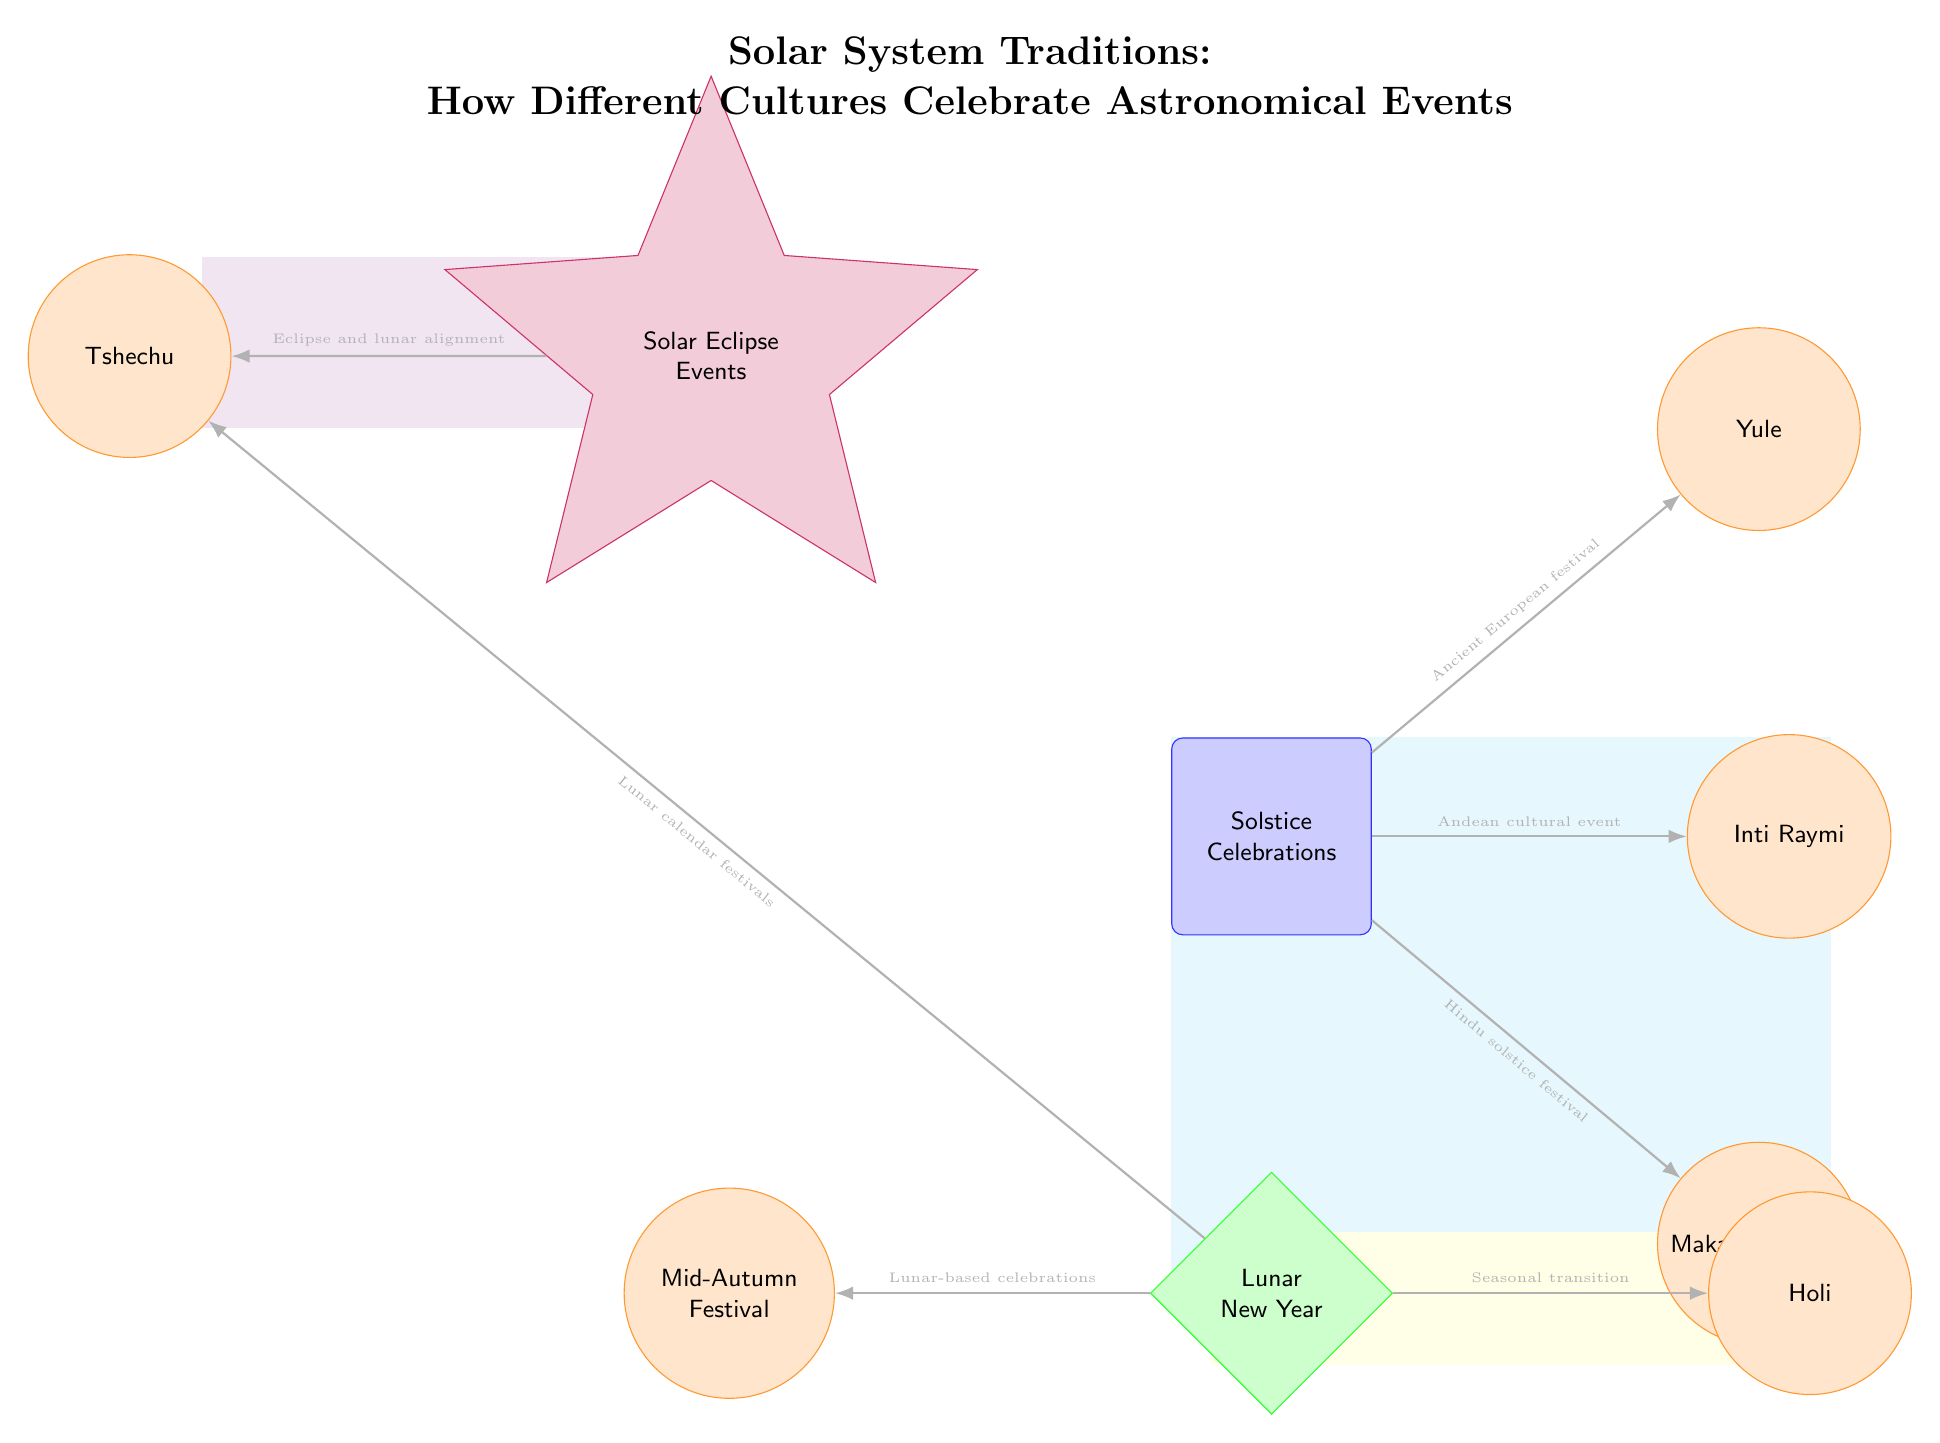What is the main theme of the diagram? The title at the top of the diagram clearly states the theme: "Solar System Traditions: How Different Cultures Celebrate Astronomical Events." This provides an overview of what the diagram will discuss.
Answer: Solar System Traditions: How Different Cultures Celebrate Astronomical Events How many solstice celebrations are shown? There are three events branching from the "Solstice Celebrations" node: Yule, Inti Raymi, and Makar Sankranti. Counting these gives a total of three solstice celebrations.
Answer: 3 Which festival is associated with the lunar calendar? The connections from the "Lunar New Year" show that Mid-Autumn Festival and Tsechu are specifically mentioned as festivals linked to the lunar calendar. Hence, either could be interpreted as an answer, but the question asks for which is directly stated as lunar-based.
Answer: Tsechu What type of event is associated with the color purple in the diagram? The diagram shows a star-shaped node colored purple labeled "Solar Eclipse Events," indicating that it deals specifically with eclipse-related celebrations and events within the diagram.
Answer: Solar Eclipse Events Which celebration is noted as an ancient European festival? The connection from "Solstice Celebrations" to "Yule" states that it is an ancient European festival. This description directly associates Yule with the ancient European tradition.
Answer: Yule How many different types of celebrations are depicted in the diagram? The diagram shows three distinct types of celebrations: solstice celebrations, lunar celebrations, and solar eclipse events. Each of these types is encapsulated in their respective colored areas.
Answer: 3 What does the connection between "Lunar New Year" and "Holi" signify? The connection notes that Holi is related to seasonal transition. Therefore, the relationship indicates that Holi celebrates a seasonal shift, which occurs alongside the Lunar New Year celebrations. This shows the importance of seasonal changes in these festivals.
Answer: Seasonal transition What type of shape represents celestial events in the diagram? The "eclipse" node is shaped like a star, indicating its unique representation of solar eclipse events. This distinct shape sets it apart from other types of events, which use different shapes.
Answer: Star Which event is identified as an Andean cultural celebration? The "Inti Raymi" is directly connected to "Solstice Celebrations" and is noted as an Andean cultural event, making it clear that this festival is closely tied to Andean traditions related to solstice phenomena.
Answer: Inti Raymi 